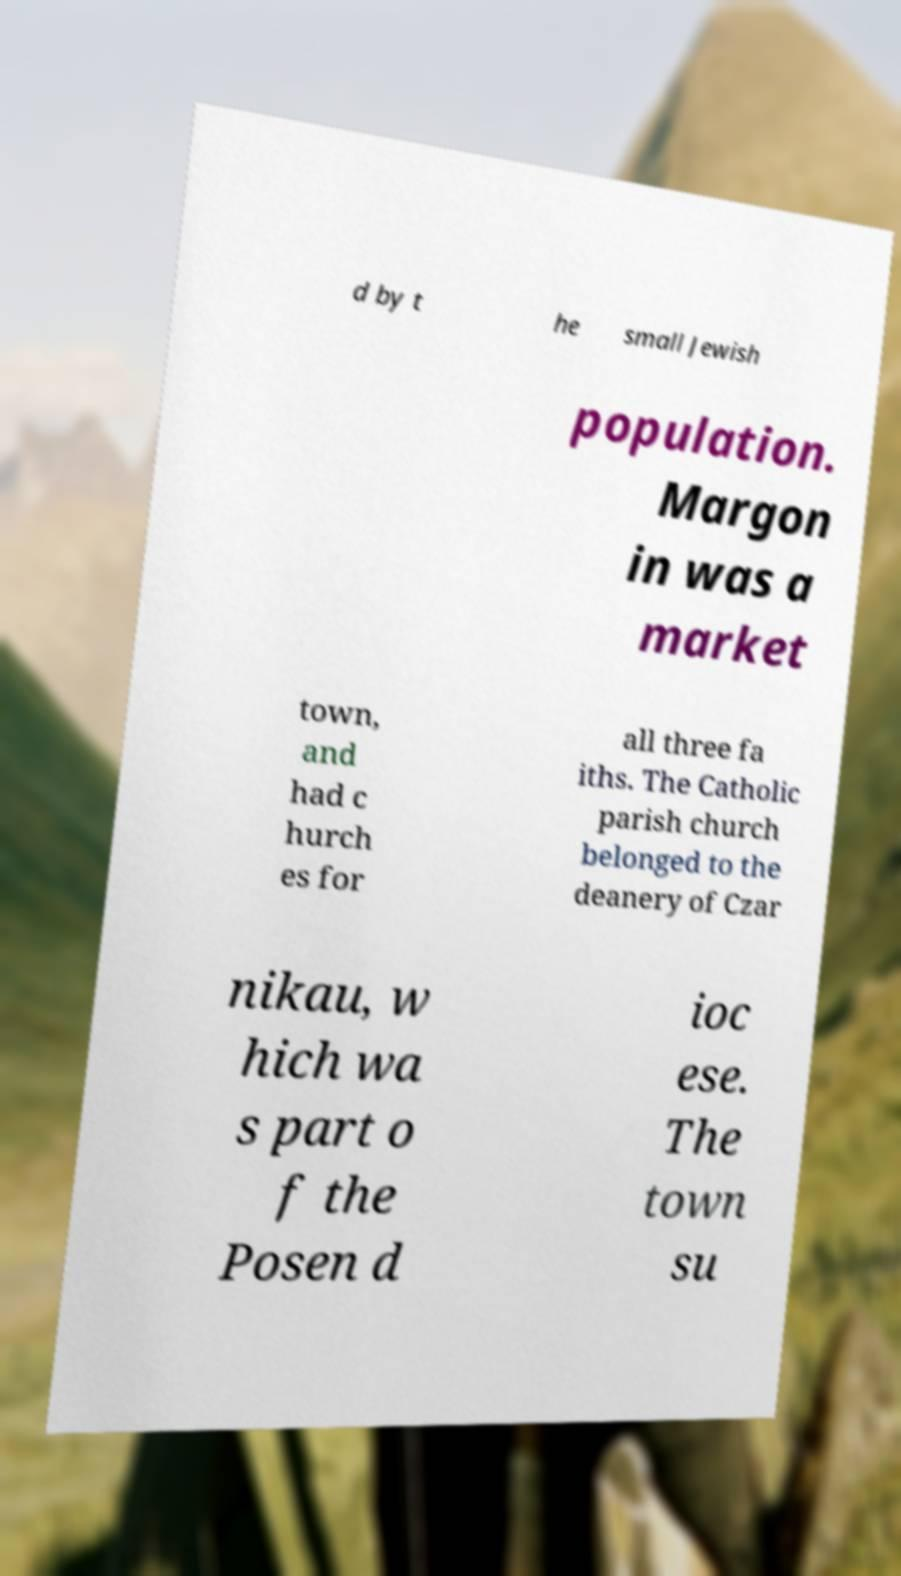Can you read and provide the text displayed in the image?This photo seems to have some interesting text. Can you extract and type it out for me? d by t he small Jewish population. Margon in was a market town, and had c hurch es for all three fa iths. The Catholic parish church belonged to the deanery of Czar nikau, w hich wa s part o f the Posen d ioc ese. The town su 